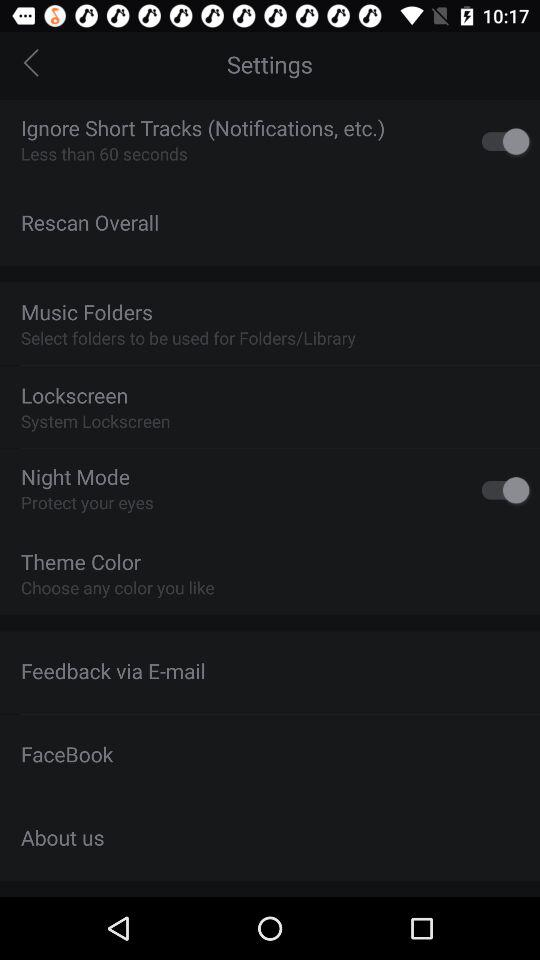How many seconds are there in "Ignore Short Tracks"? There are less than 60 seconds. 